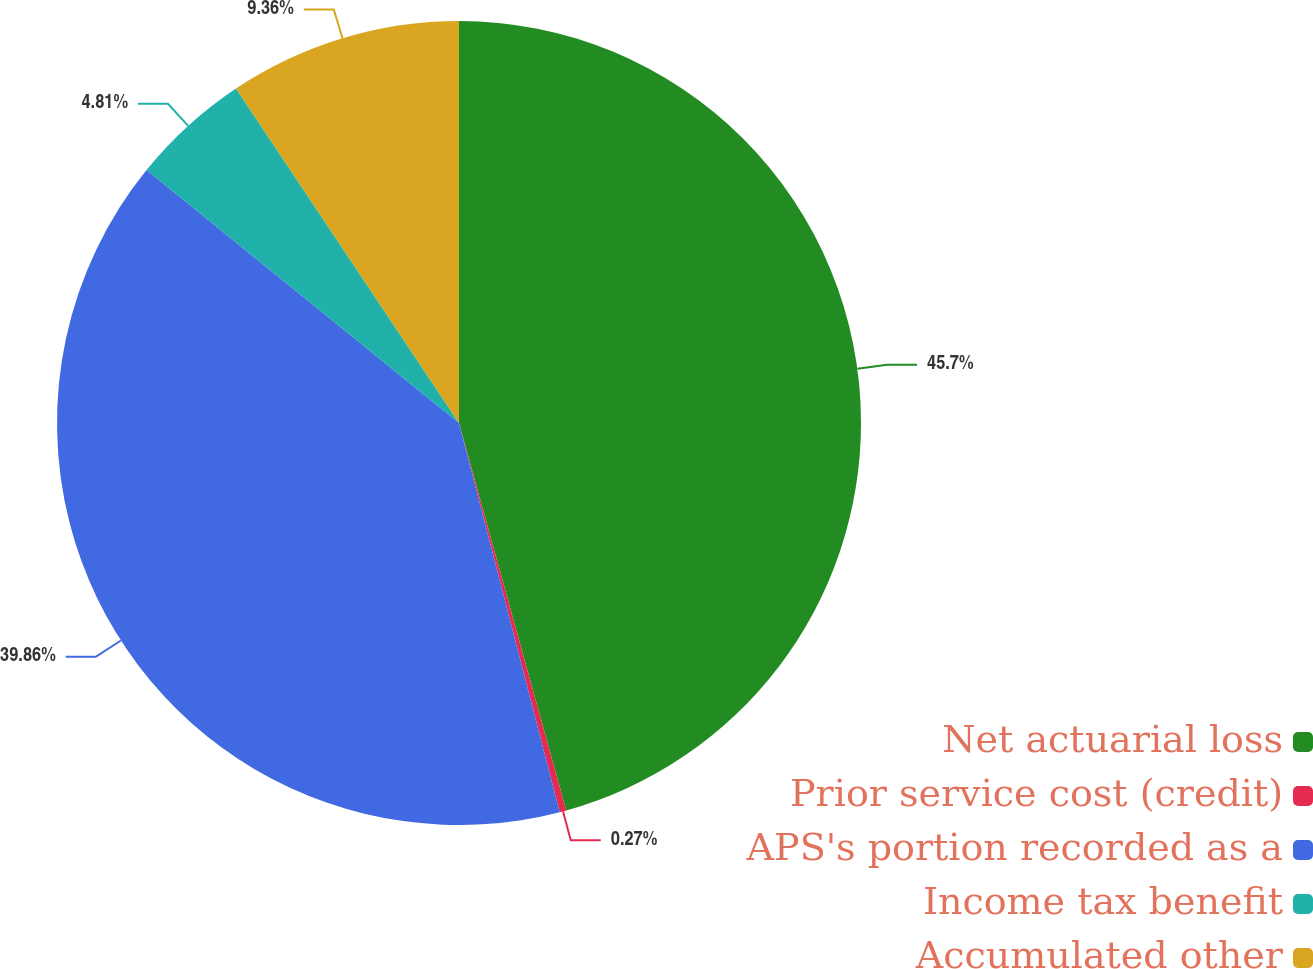Convert chart to OTSL. <chart><loc_0><loc_0><loc_500><loc_500><pie_chart><fcel>Net actuarial loss<fcel>Prior service cost (credit)<fcel>APS's portion recorded as a<fcel>Income tax benefit<fcel>Accumulated other<nl><fcel>45.7%<fcel>0.27%<fcel>39.86%<fcel>4.81%<fcel>9.36%<nl></chart> 